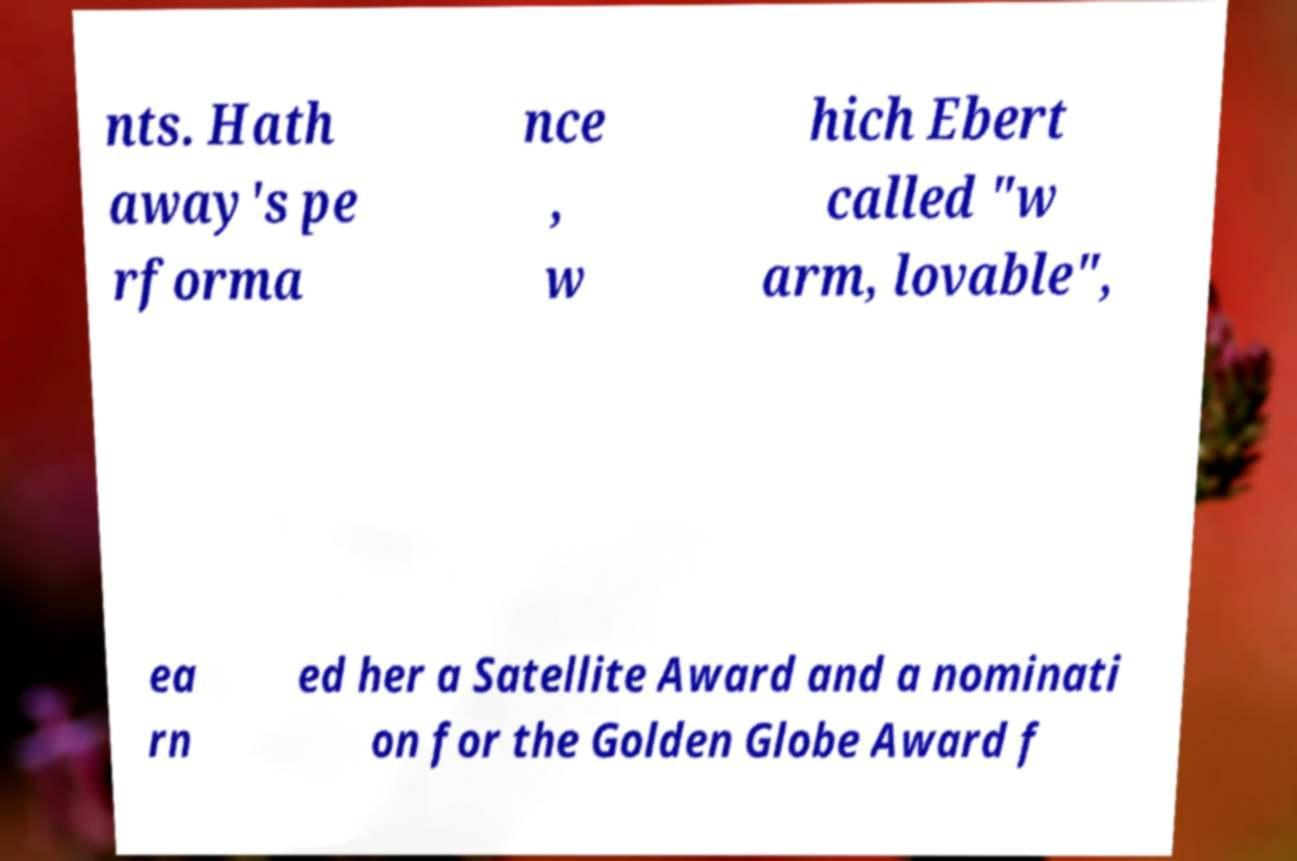Can you accurately transcribe the text from the provided image for me? nts. Hath away's pe rforma nce , w hich Ebert called "w arm, lovable", ea rn ed her a Satellite Award and a nominati on for the Golden Globe Award f 